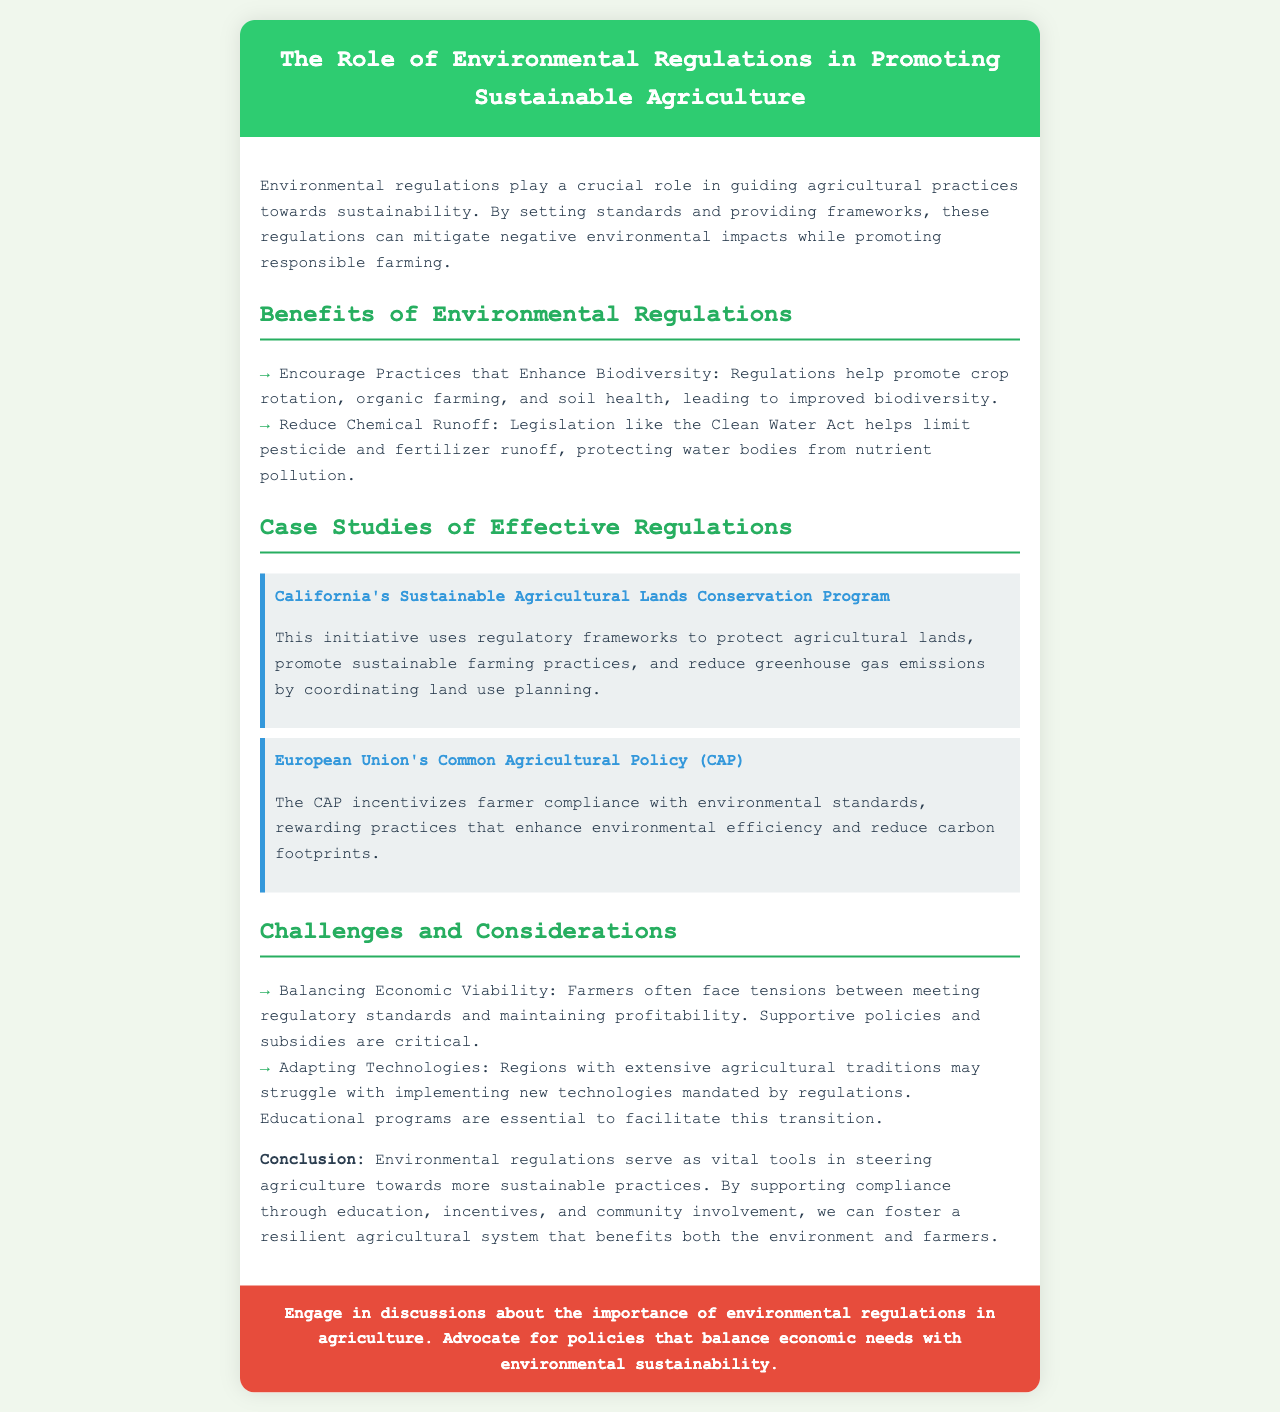What is the title of the brochure? The title is prominently displayed at the top of the document.
Answer: The Role of Environmental Regulations in Promoting Sustainable Agriculture What does the Clean Water Act help to limit? The document mentions specific legislation that controls environmental issues.
Answer: Pesticide and fertilizer runoff What is one benefit of environmental regulations mentioned? The document lists several advantages of regulations.
Answer: Enhance biodiversity What is the focus of the California initiative mentioned? The case study describes the main objectives of this program.
Answer: Protect agricultural lands What does the CAP incentivize farmers to comply with? The document details the goals of the mentioned policy.
Answer: Environmental standards What are farmers often struggling to balance? The document discusses the challenges faced by farmers and risk factors.
Answer: Economic viability What types of educational support might be essential? The challenges section mentions what can help farmers adapt.
Answer: Educational programs How many case studies are presented in the document? The case studies section provides specific examples of regulations.
Answer: Two 